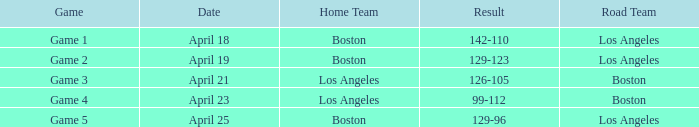WHAT GAME HAD A SCORE OF 99-112? Game 4. 